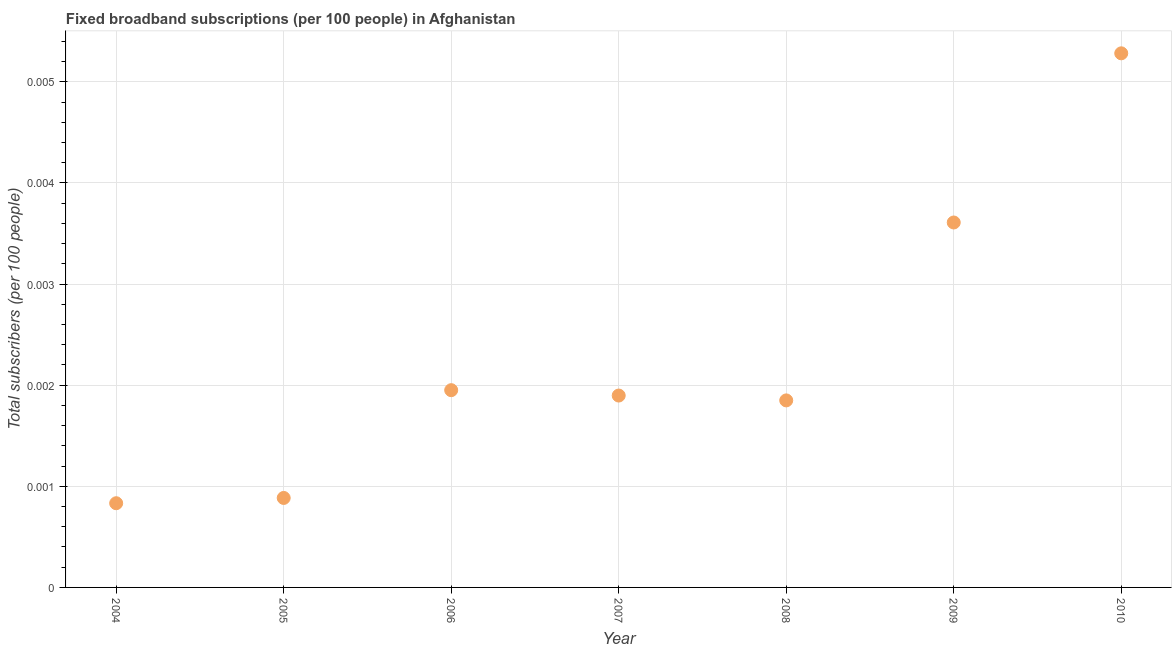What is the total number of fixed broadband subscriptions in 2009?
Keep it short and to the point. 0. Across all years, what is the maximum total number of fixed broadband subscriptions?
Provide a succinct answer. 0.01. Across all years, what is the minimum total number of fixed broadband subscriptions?
Your answer should be very brief. 0. In which year was the total number of fixed broadband subscriptions maximum?
Your answer should be very brief. 2010. What is the sum of the total number of fixed broadband subscriptions?
Provide a short and direct response. 0.02. What is the difference between the total number of fixed broadband subscriptions in 2004 and 2006?
Provide a succinct answer. -0. What is the average total number of fixed broadband subscriptions per year?
Your response must be concise. 0. What is the median total number of fixed broadband subscriptions?
Provide a succinct answer. 0. In how many years, is the total number of fixed broadband subscriptions greater than 0.0048000000000000004 ?
Offer a terse response. 1. Do a majority of the years between 2004 and 2005 (inclusive) have total number of fixed broadband subscriptions greater than 0.0012000000000000001 ?
Offer a terse response. No. What is the ratio of the total number of fixed broadband subscriptions in 2004 to that in 2007?
Your answer should be compact. 0.44. Is the total number of fixed broadband subscriptions in 2006 less than that in 2010?
Offer a terse response. Yes. Is the difference between the total number of fixed broadband subscriptions in 2006 and 2009 greater than the difference between any two years?
Offer a terse response. No. What is the difference between the highest and the second highest total number of fixed broadband subscriptions?
Provide a short and direct response. 0. Is the sum of the total number of fixed broadband subscriptions in 2005 and 2008 greater than the maximum total number of fixed broadband subscriptions across all years?
Ensure brevity in your answer.  No. What is the difference between the highest and the lowest total number of fixed broadband subscriptions?
Offer a very short reply. 0. Does the total number of fixed broadband subscriptions monotonically increase over the years?
Provide a short and direct response. No. How many years are there in the graph?
Offer a very short reply. 7. Are the values on the major ticks of Y-axis written in scientific E-notation?
Offer a terse response. No. Does the graph contain grids?
Your answer should be very brief. Yes. What is the title of the graph?
Offer a terse response. Fixed broadband subscriptions (per 100 people) in Afghanistan. What is the label or title of the X-axis?
Your answer should be compact. Year. What is the label or title of the Y-axis?
Your answer should be very brief. Total subscribers (per 100 people). What is the Total subscribers (per 100 people) in 2004?
Your response must be concise. 0. What is the Total subscribers (per 100 people) in 2005?
Give a very brief answer. 0. What is the Total subscribers (per 100 people) in 2006?
Your answer should be compact. 0. What is the Total subscribers (per 100 people) in 2007?
Make the answer very short. 0. What is the Total subscribers (per 100 people) in 2008?
Give a very brief answer. 0. What is the Total subscribers (per 100 people) in 2009?
Your response must be concise. 0. What is the Total subscribers (per 100 people) in 2010?
Your answer should be very brief. 0.01. What is the difference between the Total subscribers (per 100 people) in 2004 and 2005?
Provide a short and direct response. -5e-5. What is the difference between the Total subscribers (per 100 people) in 2004 and 2006?
Keep it short and to the point. -0. What is the difference between the Total subscribers (per 100 people) in 2004 and 2007?
Give a very brief answer. -0. What is the difference between the Total subscribers (per 100 people) in 2004 and 2008?
Ensure brevity in your answer.  -0. What is the difference between the Total subscribers (per 100 people) in 2004 and 2009?
Provide a succinct answer. -0. What is the difference between the Total subscribers (per 100 people) in 2004 and 2010?
Provide a short and direct response. -0. What is the difference between the Total subscribers (per 100 people) in 2005 and 2006?
Provide a short and direct response. -0. What is the difference between the Total subscribers (per 100 people) in 2005 and 2007?
Provide a succinct answer. -0. What is the difference between the Total subscribers (per 100 people) in 2005 and 2008?
Keep it short and to the point. -0. What is the difference between the Total subscribers (per 100 people) in 2005 and 2009?
Provide a succinct answer. -0. What is the difference between the Total subscribers (per 100 people) in 2005 and 2010?
Offer a terse response. -0. What is the difference between the Total subscribers (per 100 people) in 2006 and 2007?
Make the answer very short. 5e-5. What is the difference between the Total subscribers (per 100 people) in 2006 and 2008?
Make the answer very short. 0. What is the difference between the Total subscribers (per 100 people) in 2006 and 2009?
Provide a succinct answer. -0. What is the difference between the Total subscribers (per 100 people) in 2006 and 2010?
Make the answer very short. -0. What is the difference between the Total subscribers (per 100 people) in 2007 and 2008?
Offer a very short reply. 5e-5. What is the difference between the Total subscribers (per 100 people) in 2007 and 2009?
Provide a succinct answer. -0. What is the difference between the Total subscribers (per 100 people) in 2007 and 2010?
Offer a terse response. -0. What is the difference between the Total subscribers (per 100 people) in 2008 and 2009?
Offer a very short reply. -0. What is the difference between the Total subscribers (per 100 people) in 2008 and 2010?
Provide a short and direct response. -0. What is the difference between the Total subscribers (per 100 people) in 2009 and 2010?
Your answer should be very brief. -0. What is the ratio of the Total subscribers (per 100 people) in 2004 to that in 2005?
Keep it short and to the point. 0.94. What is the ratio of the Total subscribers (per 100 people) in 2004 to that in 2006?
Give a very brief answer. 0.43. What is the ratio of the Total subscribers (per 100 people) in 2004 to that in 2007?
Provide a short and direct response. 0.44. What is the ratio of the Total subscribers (per 100 people) in 2004 to that in 2008?
Offer a terse response. 0.45. What is the ratio of the Total subscribers (per 100 people) in 2004 to that in 2009?
Make the answer very short. 0.23. What is the ratio of the Total subscribers (per 100 people) in 2004 to that in 2010?
Provide a short and direct response. 0.16. What is the ratio of the Total subscribers (per 100 people) in 2005 to that in 2006?
Your answer should be very brief. 0.45. What is the ratio of the Total subscribers (per 100 people) in 2005 to that in 2007?
Your response must be concise. 0.47. What is the ratio of the Total subscribers (per 100 people) in 2005 to that in 2008?
Your answer should be compact. 0.48. What is the ratio of the Total subscribers (per 100 people) in 2005 to that in 2009?
Provide a short and direct response. 0.24. What is the ratio of the Total subscribers (per 100 people) in 2005 to that in 2010?
Your answer should be very brief. 0.17. What is the ratio of the Total subscribers (per 100 people) in 2006 to that in 2007?
Offer a very short reply. 1.03. What is the ratio of the Total subscribers (per 100 people) in 2006 to that in 2008?
Give a very brief answer. 1.05. What is the ratio of the Total subscribers (per 100 people) in 2006 to that in 2009?
Keep it short and to the point. 0.54. What is the ratio of the Total subscribers (per 100 people) in 2006 to that in 2010?
Your answer should be very brief. 0.37. What is the ratio of the Total subscribers (per 100 people) in 2007 to that in 2008?
Offer a terse response. 1.03. What is the ratio of the Total subscribers (per 100 people) in 2007 to that in 2009?
Provide a succinct answer. 0.53. What is the ratio of the Total subscribers (per 100 people) in 2007 to that in 2010?
Offer a terse response. 0.36. What is the ratio of the Total subscribers (per 100 people) in 2008 to that in 2009?
Provide a short and direct response. 0.51. What is the ratio of the Total subscribers (per 100 people) in 2009 to that in 2010?
Provide a short and direct response. 0.68. 